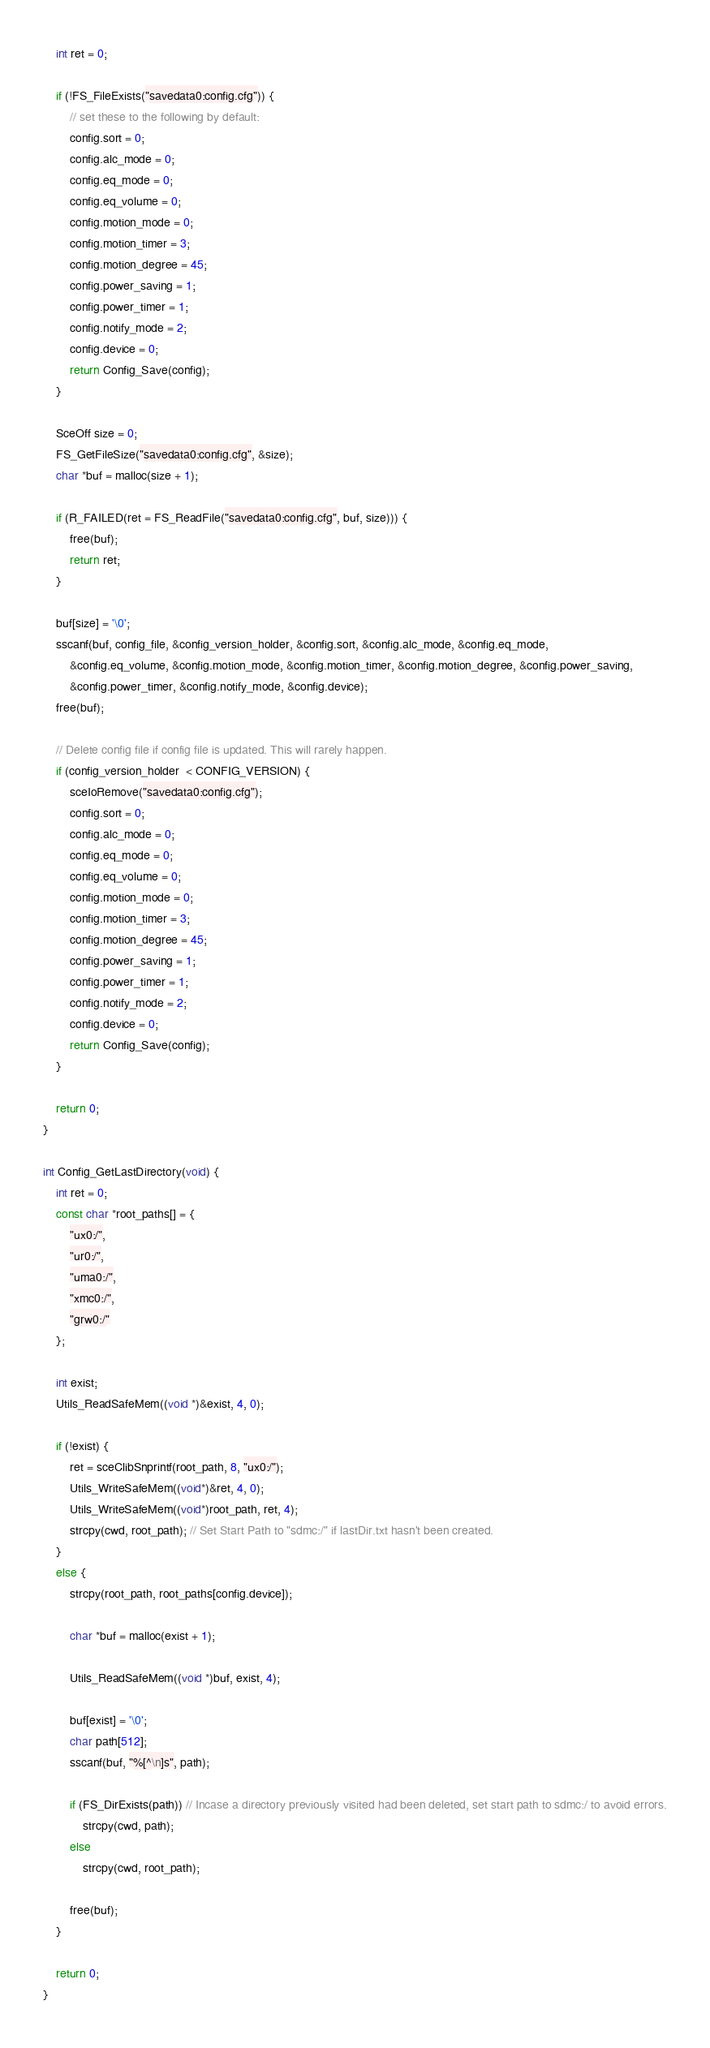Convert code to text. <code><loc_0><loc_0><loc_500><loc_500><_C_>	int ret = 0;
	
	if (!FS_FileExists("savedata0:config.cfg")) {
		// set these to the following by default:
		config.sort = 0;
		config.alc_mode = 0;
		config.eq_mode = 0;
		config.eq_volume = 0;
		config.motion_mode = 0;
		config.motion_timer = 3;
		config.motion_degree = 45;
		config.power_saving = 1;
		config.power_timer = 1;
		config.notify_mode = 2;
		config.device = 0;
		return Config_Save(config);
	}

	SceOff size = 0;
	FS_GetFileSize("savedata0:config.cfg", &size);
	char *buf = malloc(size + 1);

	if (R_FAILED(ret = FS_ReadFile("savedata0:config.cfg", buf, size))) {
		free(buf);
		return ret;
	}

	buf[size] = '\0';
	sscanf(buf, config_file, &config_version_holder, &config.sort, &config.alc_mode, &config.eq_mode,
		&config.eq_volume, &config.motion_mode, &config.motion_timer, &config.motion_degree, &config.power_saving,
		&config.power_timer, &config.notify_mode, &config.device);
	free(buf);

	// Delete config file if config file is updated. This will rarely happen.
	if (config_version_holder  < CONFIG_VERSION) {
		sceIoRemove("savedata0:config.cfg");
		config.sort = 0;
		config.alc_mode = 0;
		config.eq_mode = 0;
		config.eq_volume = 0;
		config.motion_mode = 0;
		config.motion_timer = 3;
		config.motion_degree = 45;
		config.power_saving = 1;
		config.power_timer = 1;
		config.notify_mode = 2;
		config.device = 0;
		return Config_Save(config);
	}

	return 0;
}

int Config_GetLastDirectory(void) {
	int ret = 0;
	const char *root_paths[] = {
		"ux0:/",
		"ur0:/",
		"uma0:/",
		"xmc0:/",
		"grw0:/"
	};
	
	int exist;
	Utils_ReadSafeMem((void *)&exist, 4, 0);

	if (!exist) {
		ret = sceClibSnprintf(root_path, 8, "ux0:/");
		Utils_WriteSafeMem((void*)&ret, 4, 0);
		Utils_WriteSafeMem((void*)root_path, ret, 4);
		strcpy(cwd, root_path); // Set Start Path to "sdmc:/" if lastDir.txt hasn't been created.
	}
	else {
		strcpy(root_path, root_paths[config.device]);

		char *buf = malloc(exist + 1);

		Utils_ReadSafeMem((void *)buf, exist, 4);

		buf[exist] = '\0';
		char path[512];
		sscanf(buf, "%[^\n]s", path);
	
		if (FS_DirExists(path)) // Incase a directory previously visited had been deleted, set start path to sdmc:/ to avoid errors.
			strcpy(cwd, path);
		else
			strcpy(cwd, root_path);
		
		free(buf);
	}
	
	return 0;
}
</code> 